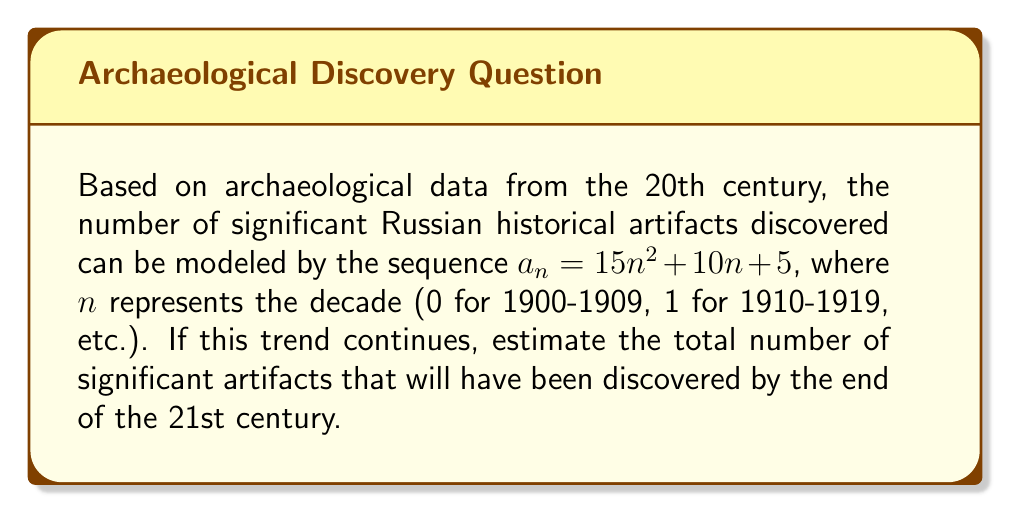Can you answer this question? 1) First, we need to calculate the sum of discoveries for the 20th century (10 decades):
   $$S_{20th} = \sum_{n=0}^9 (15n^2 + 10n + 5)$$

2) We can use the formulas for the sum of squares and sum of natural numbers:
   $$\sum_{n=1}^k n^2 = \frac{k(k+1)(2k+1)}{6}$$
   $$\sum_{n=1}^k n = \frac{k(k+1)}{2}$$

3) Adjusting for our sequence starting at 0:
   $$S_{20th} = 15 \cdot \frac{9 \cdot 10 \cdot 19}{6} + 10 \cdot \frac{9 \cdot 10}{2} + 5 \cdot 10 = 4275 + 450 + 50 = 4775$$

4) For the 21st century, we continue the sequence for 10 more terms (n = 10 to 19):
   $$S_{21st} = \sum_{n=10}^{19} (15n^2 + 10n + 5)$$

5) Using the same formulas:
   $$S_{21st} = 15 \cdot (\frac{19 \cdot 20 \cdot 39}{6} - \frac{9 \cdot 10 \cdot 19}{6}) + 10 \cdot (\frac{19 \cdot 20}{2} - \frac{9 \cdot 10}{2}) + 5 \cdot 10$$
   $$= 15 \cdot 1330 + 10 \cdot 145 + 50 = 19950 + 1450 + 50 = 21450$$

6) The total number of artifacts by the end of the 21st century:
   $$S_{total} = S_{20th} + S_{21st} = 4775 + 21450 = 26225$$
Answer: 26225 artifacts 